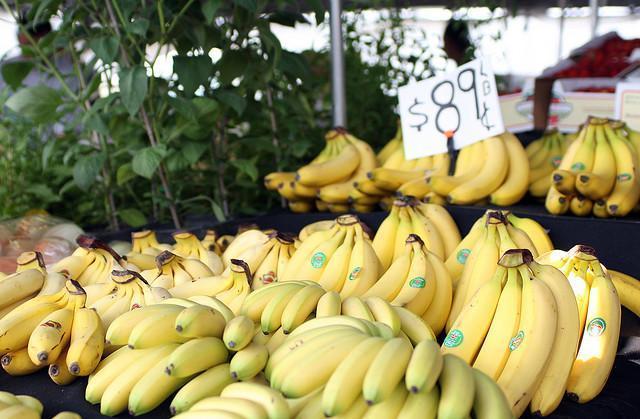How many bananas are there?
Give a very brief answer. 11. 